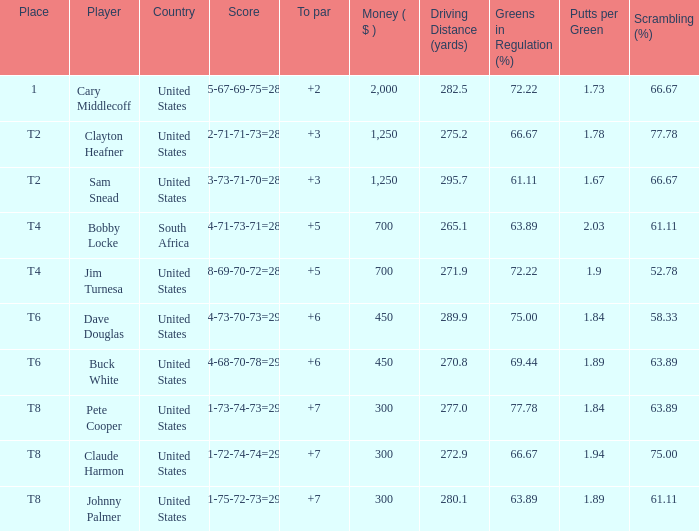What is the Johnny Palmer with a To larger than 6 Money sum? 300.0. 